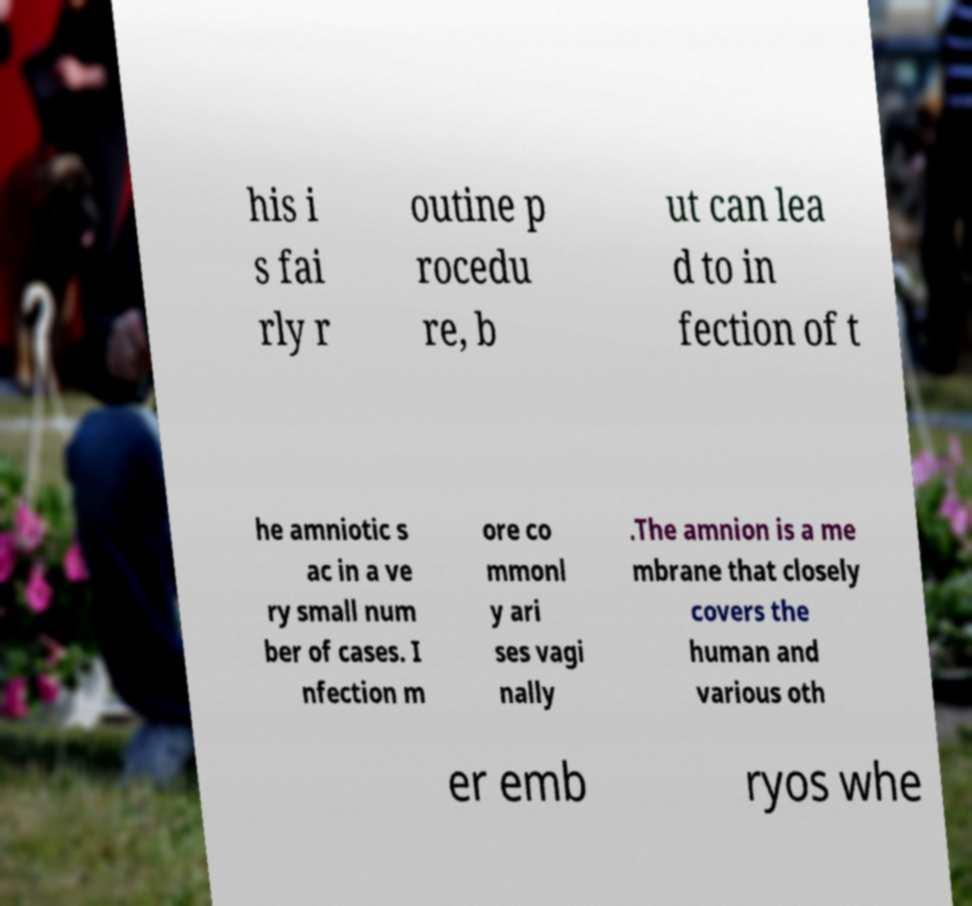I need the written content from this picture converted into text. Can you do that? his i s fai rly r outine p rocedu re, b ut can lea d to in fection of t he amniotic s ac in a ve ry small num ber of cases. I nfection m ore co mmonl y ari ses vagi nally .The amnion is a me mbrane that closely covers the human and various oth er emb ryos whe 